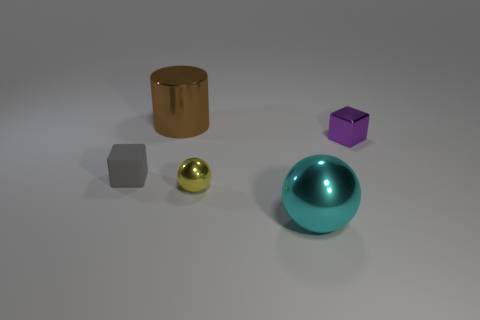Is there any other thing that is the same material as the gray object?
Your answer should be very brief. No. Are there fewer purple blocks than blue metallic cylinders?
Your response must be concise. No. Are there any spheres that have the same material as the small purple block?
Your response must be concise. Yes. What shape is the big object in front of the small purple cube?
Give a very brief answer. Sphere. Do the metallic ball that is right of the tiny yellow ball and the tiny rubber block have the same color?
Offer a terse response. No. Is the number of small yellow shiny balls that are behind the gray cube less than the number of big cyan balls?
Keep it short and to the point. Yes. There is another tiny thing that is made of the same material as the small purple thing; what is its color?
Offer a very short reply. Yellow. There is a metallic sphere that is to the left of the big cyan thing; how big is it?
Ensure brevity in your answer.  Small. Is the material of the purple object the same as the small gray thing?
Provide a succinct answer. No. Is there a purple object that is to the right of the tiny thing behind the tiny cube left of the brown cylinder?
Provide a short and direct response. No. 